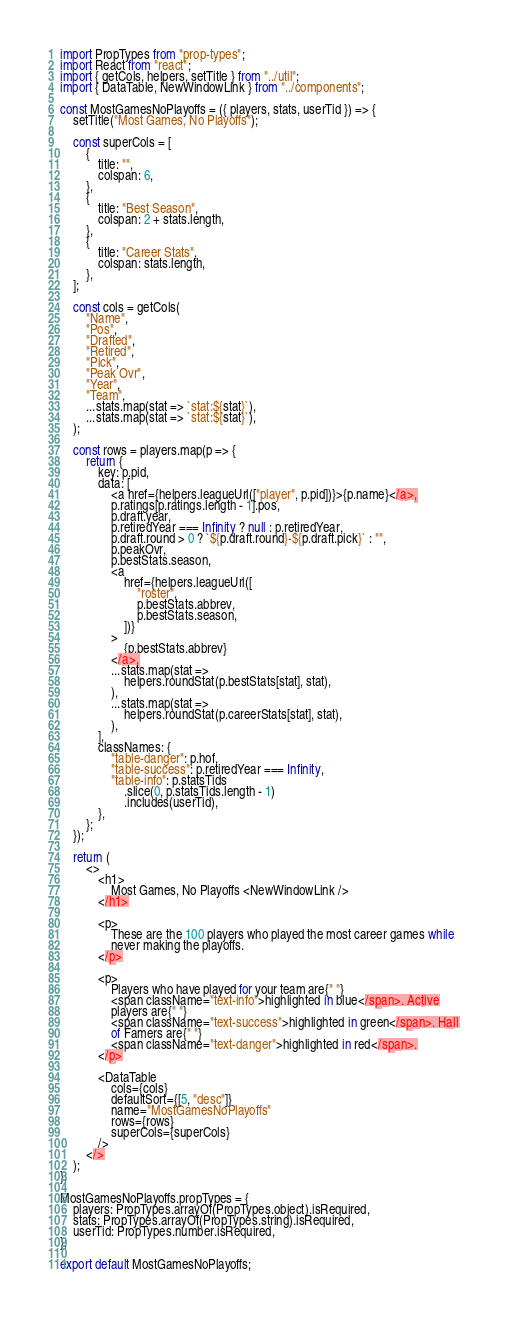<code> <loc_0><loc_0><loc_500><loc_500><_JavaScript_>import PropTypes from "prop-types";
import React from "react";
import { getCols, helpers, setTitle } from "../util";
import { DataTable, NewWindowLink } from "../components";

const MostGamesNoPlayoffs = ({ players, stats, userTid }) => {
    setTitle("Most Games, No Playoffs");

    const superCols = [
        {
            title: "",
            colspan: 6,
        },
        {
            title: "Best Season",
            colspan: 2 + stats.length,
        },
        {
            title: "Career Stats",
            colspan: stats.length,
        },
    ];

    const cols = getCols(
        "Name",
        "Pos",
        "Drafted",
        "Retired",
        "Pick",
        "Peak Ovr",
        "Year",
        "Team",
        ...stats.map(stat => `stat:${stat}`),
        ...stats.map(stat => `stat:${stat}`),
    );

    const rows = players.map(p => {
        return {
            key: p.pid,
            data: [
                <a href={helpers.leagueUrl(["player", p.pid])}>{p.name}</a>,
                p.ratings[p.ratings.length - 1].pos,
                p.draft.year,
                p.retiredYear === Infinity ? null : p.retiredYear,
                p.draft.round > 0 ? `${p.draft.round}-${p.draft.pick}` : "",
                p.peakOvr,
                p.bestStats.season,
                <a
                    href={helpers.leagueUrl([
                        "roster",
                        p.bestStats.abbrev,
                        p.bestStats.season,
                    ])}
                >
                    {p.bestStats.abbrev}
                </a>,
                ...stats.map(stat =>
                    helpers.roundStat(p.bestStats[stat], stat),
                ),
                ...stats.map(stat =>
                    helpers.roundStat(p.careerStats[stat], stat),
                ),
            ],
            classNames: {
                "table-danger": p.hof,
                "table-success": p.retiredYear === Infinity,
                "table-info": p.statsTids
                    .slice(0, p.statsTids.length - 1)
                    .includes(userTid),
            },
        };
    });

    return (
        <>
            <h1>
                Most Games, No Playoffs <NewWindowLink />
            </h1>

            <p>
                These are the 100 players who played the most career games while
                never making the playoffs.
            </p>

            <p>
                Players who have played for your team are{" "}
                <span className="text-info">highlighted in blue</span>. Active
                players are{" "}
                <span className="text-success">highlighted in green</span>. Hall
                of Famers are{" "}
                <span className="text-danger">highlighted in red</span>.
            </p>

            <DataTable
                cols={cols}
                defaultSort={[5, "desc"]}
                name="MostGamesNoPlayoffs"
                rows={rows}
                superCols={superCols}
            />
        </>
    );
};

MostGamesNoPlayoffs.propTypes = {
    players: PropTypes.arrayOf(PropTypes.object).isRequired,
    stats: PropTypes.arrayOf(PropTypes.string).isRequired,
    userTid: PropTypes.number.isRequired,
};

export default MostGamesNoPlayoffs;
</code> 